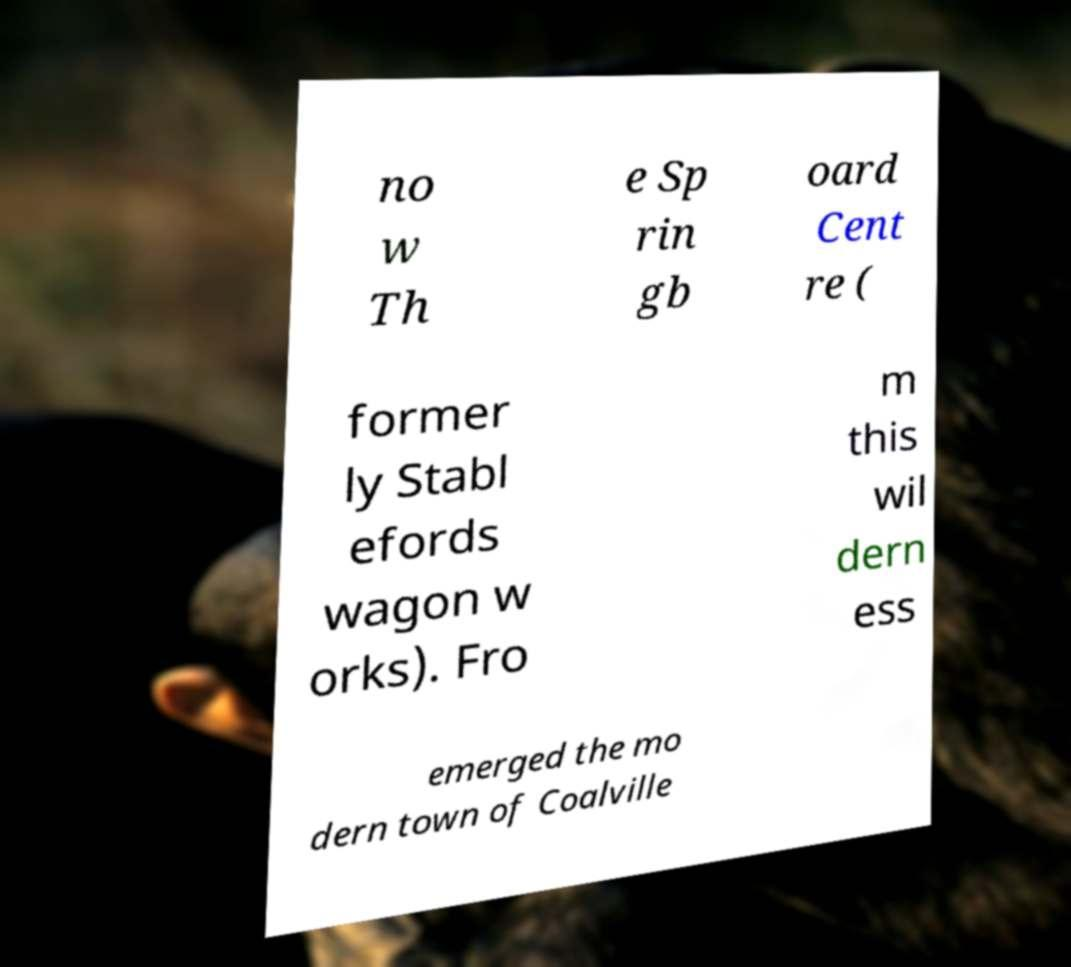For documentation purposes, I need the text within this image transcribed. Could you provide that? no w Th e Sp rin gb oard Cent re ( former ly Stabl efords wagon w orks). Fro m this wil dern ess emerged the mo dern town of Coalville 